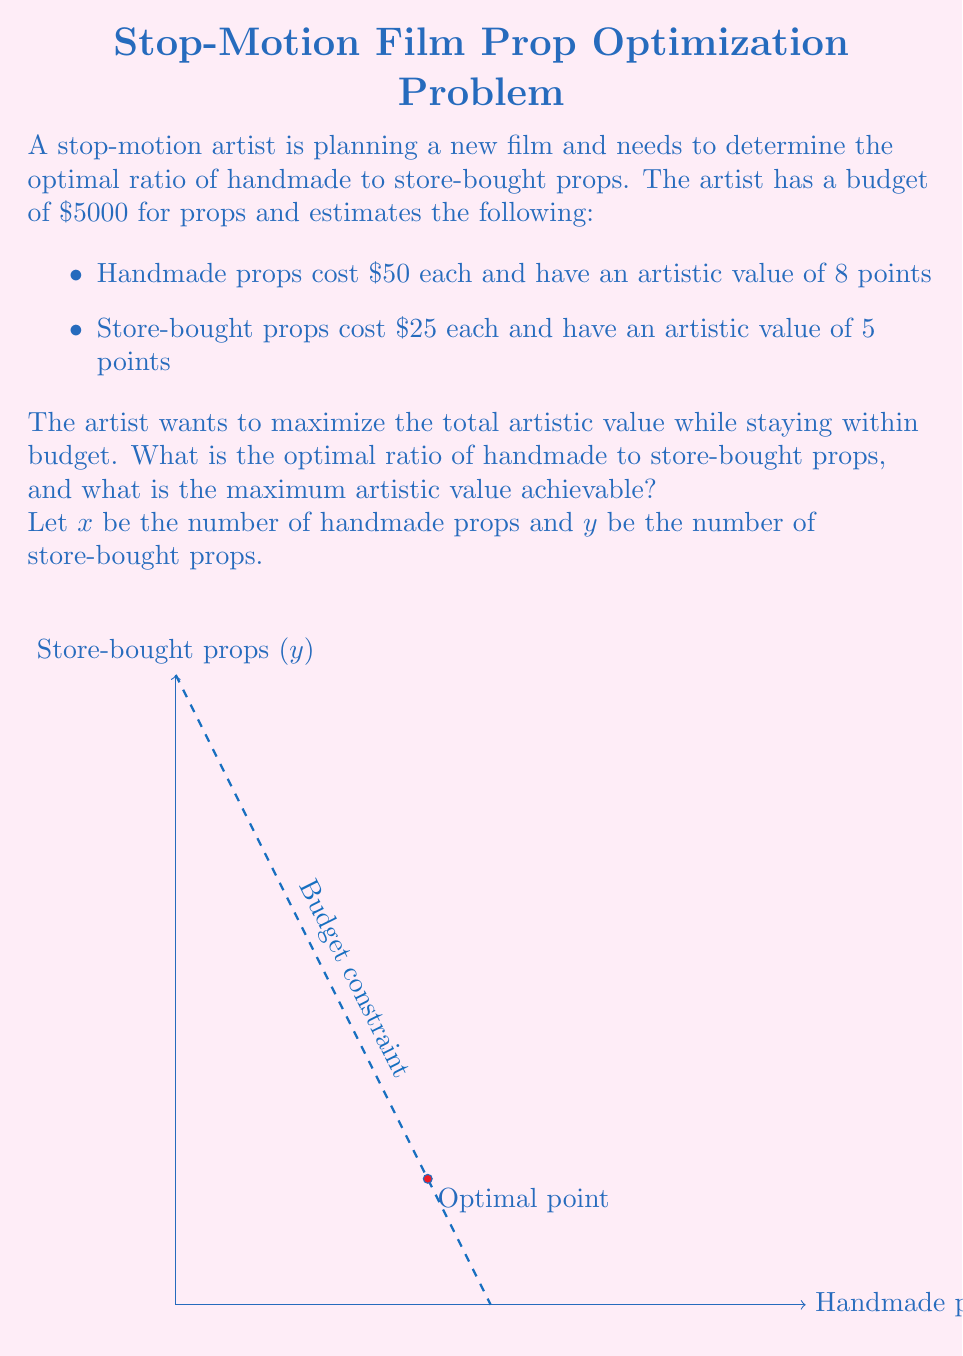Give your solution to this math problem. Let's approach this problem step-by-step using linear programming:

1) First, we need to set up our constraints:

   Budget constraint: $50x + 25y \leq 5000$
   Non-negativity: $x \geq 0$, $y \geq 0$

2) Our objective function is to maximize the artistic value:

   $\text{Maximize } Z = 8x + 5y$

3) We can solve this graphically or using the simplex method. Let's use the graphical method:

4) Plot the budget constraint: $50x + 25y = 5000$
   When $x = 0$, $y = 200$
   When $y = 0$, $x = 100$

5) The feasible region is the triangle formed by this line and the positive x and y axes.

6) The optimal solution will be at one of the corner points of this feasible region.

7) Let's evaluate the objective function at each corner point:
   (0, 0): $Z = 0$
   (100, 0): $Z = 800$
   (0, 200): $Z = 1000$

8) The point (80, 40) also satisfies the budget constraint:
   $50(80) + 25(40) = 5000$
   At this point: $Z = 8(80) + 5(40) = 840$

9) The optimal solution is at (0, 200), which means using all store-bought props.

10) To find the ratio, we compare 0 handmade props to 200 store-bought props.

11) The maximum artistic value achievable is 1000 points.
Answer: Optimal ratio of handmade to store-bought props: $0:200 = 0:1$. Maximum artistic value: 1000 points. 